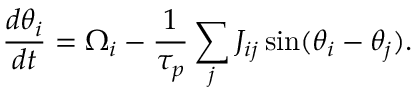<formula> <loc_0><loc_0><loc_500><loc_500>\frac { d \theta _ { i } } { d t } = \Omega _ { i } - \frac { 1 } { \tau _ { p } } \sum _ { j } J _ { i j } \sin ( \theta _ { i } - \theta _ { j } ) .</formula> 